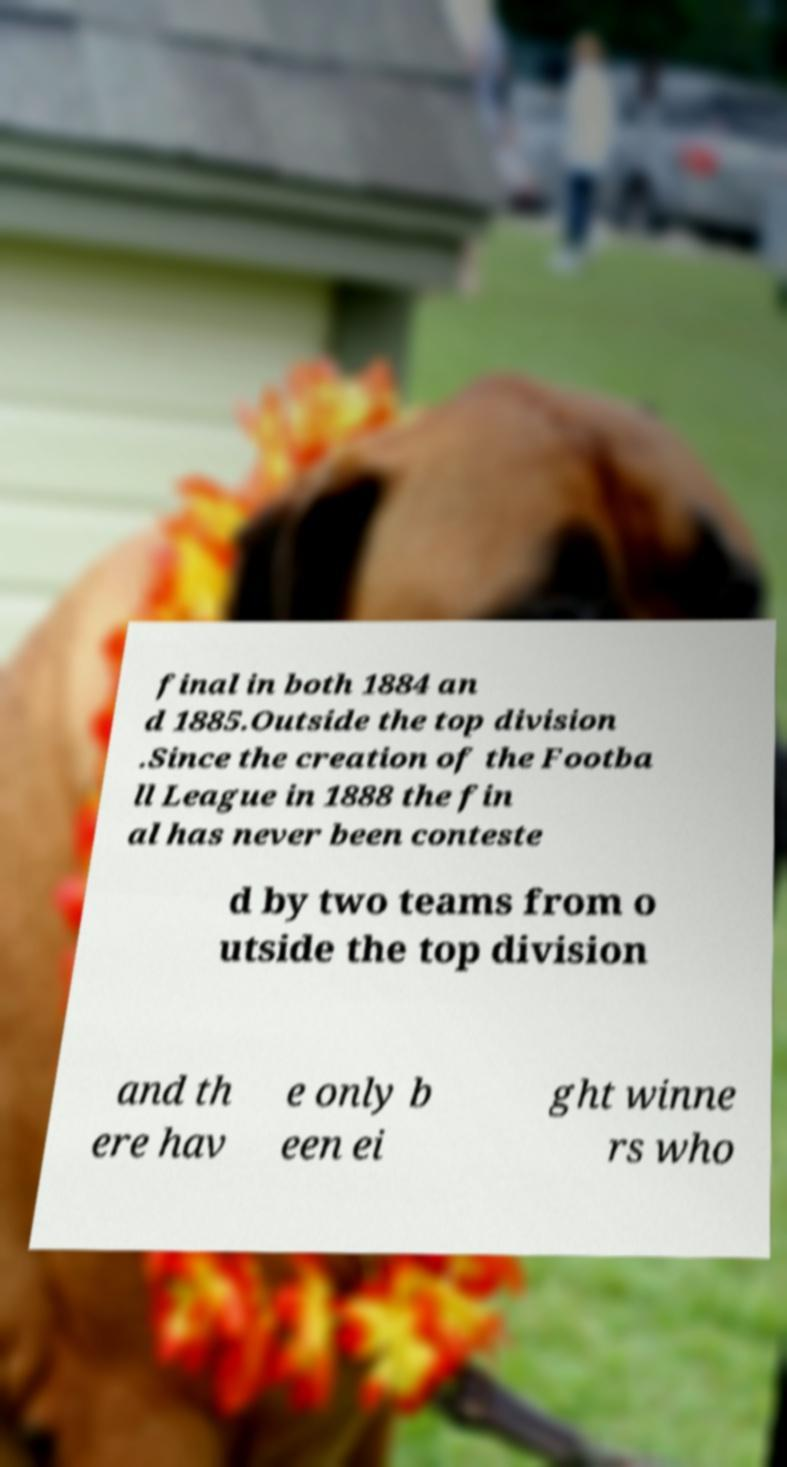Could you assist in decoding the text presented in this image and type it out clearly? final in both 1884 an d 1885.Outside the top division .Since the creation of the Footba ll League in 1888 the fin al has never been conteste d by two teams from o utside the top division and th ere hav e only b een ei ght winne rs who 